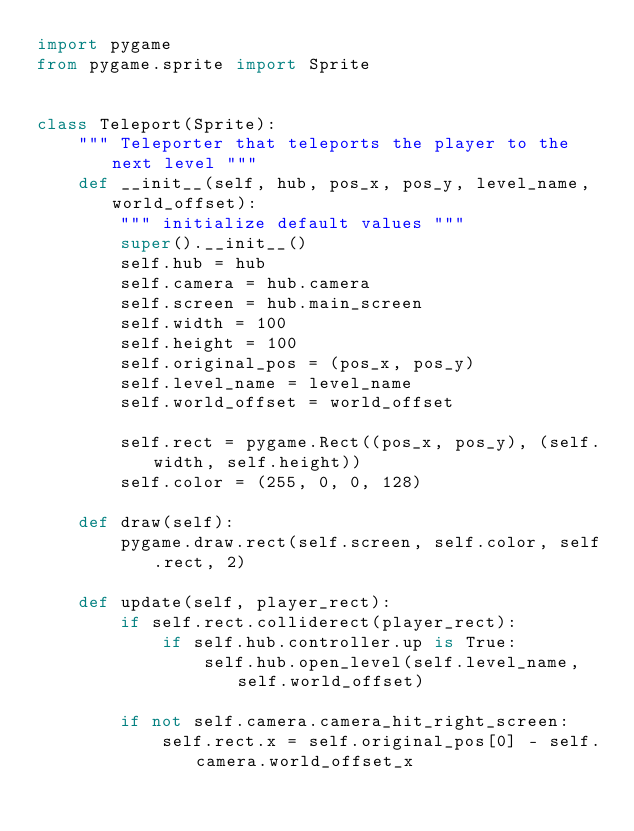<code> <loc_0><loc_0><loc_500><loc_500><_Python_>import pygame
from pygame.sprite import Sprite


class Teleport(Sprite):
    """ Teleporter that teleports the player to the next level """
    def __init__(self, hub, pos_x, pos_y, level_name, world_offset):
        """ initialize default values """
        super().__init__()
        self.hub = hub
        self.camera = hub.camera
        self.screen = hub.main_screen
        self.width = 100
        self.height = 100
        self.original_pos = (pos_x, pos_y)
        self.level_name = level_name
        self.world_offset = world_offset

        self.rect = pygame.Rect((pos_x, pos_y), (self.width, self.height))
        self.color = (255, 0, 0, 128)

    def draw(self):
        pygame.draw.rect(self.screen, self.color, self.rect, 2)

    def update(self, player_rect):
        if self.rect.colliderect(player_rect):
            if self.hub.controller.up is True:
                self.hub.open_level(self.level_name, self.world_offset)

        if not self.camera.camera_hit_right_screen:
            self.rect.x = self.original_pos[0] - self.camera.world_offset_x
</code> 